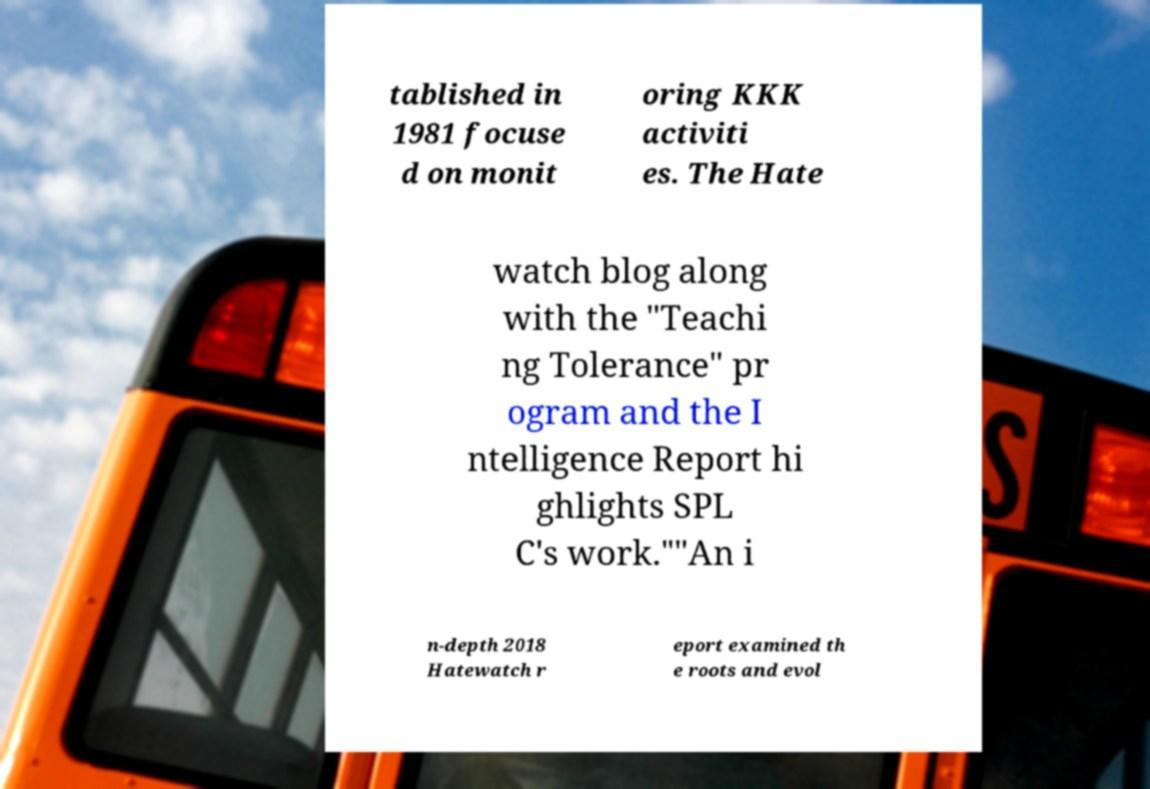What messages or text are displayed in this image? I need them in a readable, typed format. tablished in 1981 focuse d on monit oring KKK activiti es. The Hate watch blog along with the "Teachi ng Tolerance" pr ogram and the I ntelligence Report hi ghlights SPL C's work.""An i n-depth 2018 Hatewatch r eport examined th e roots and evol 